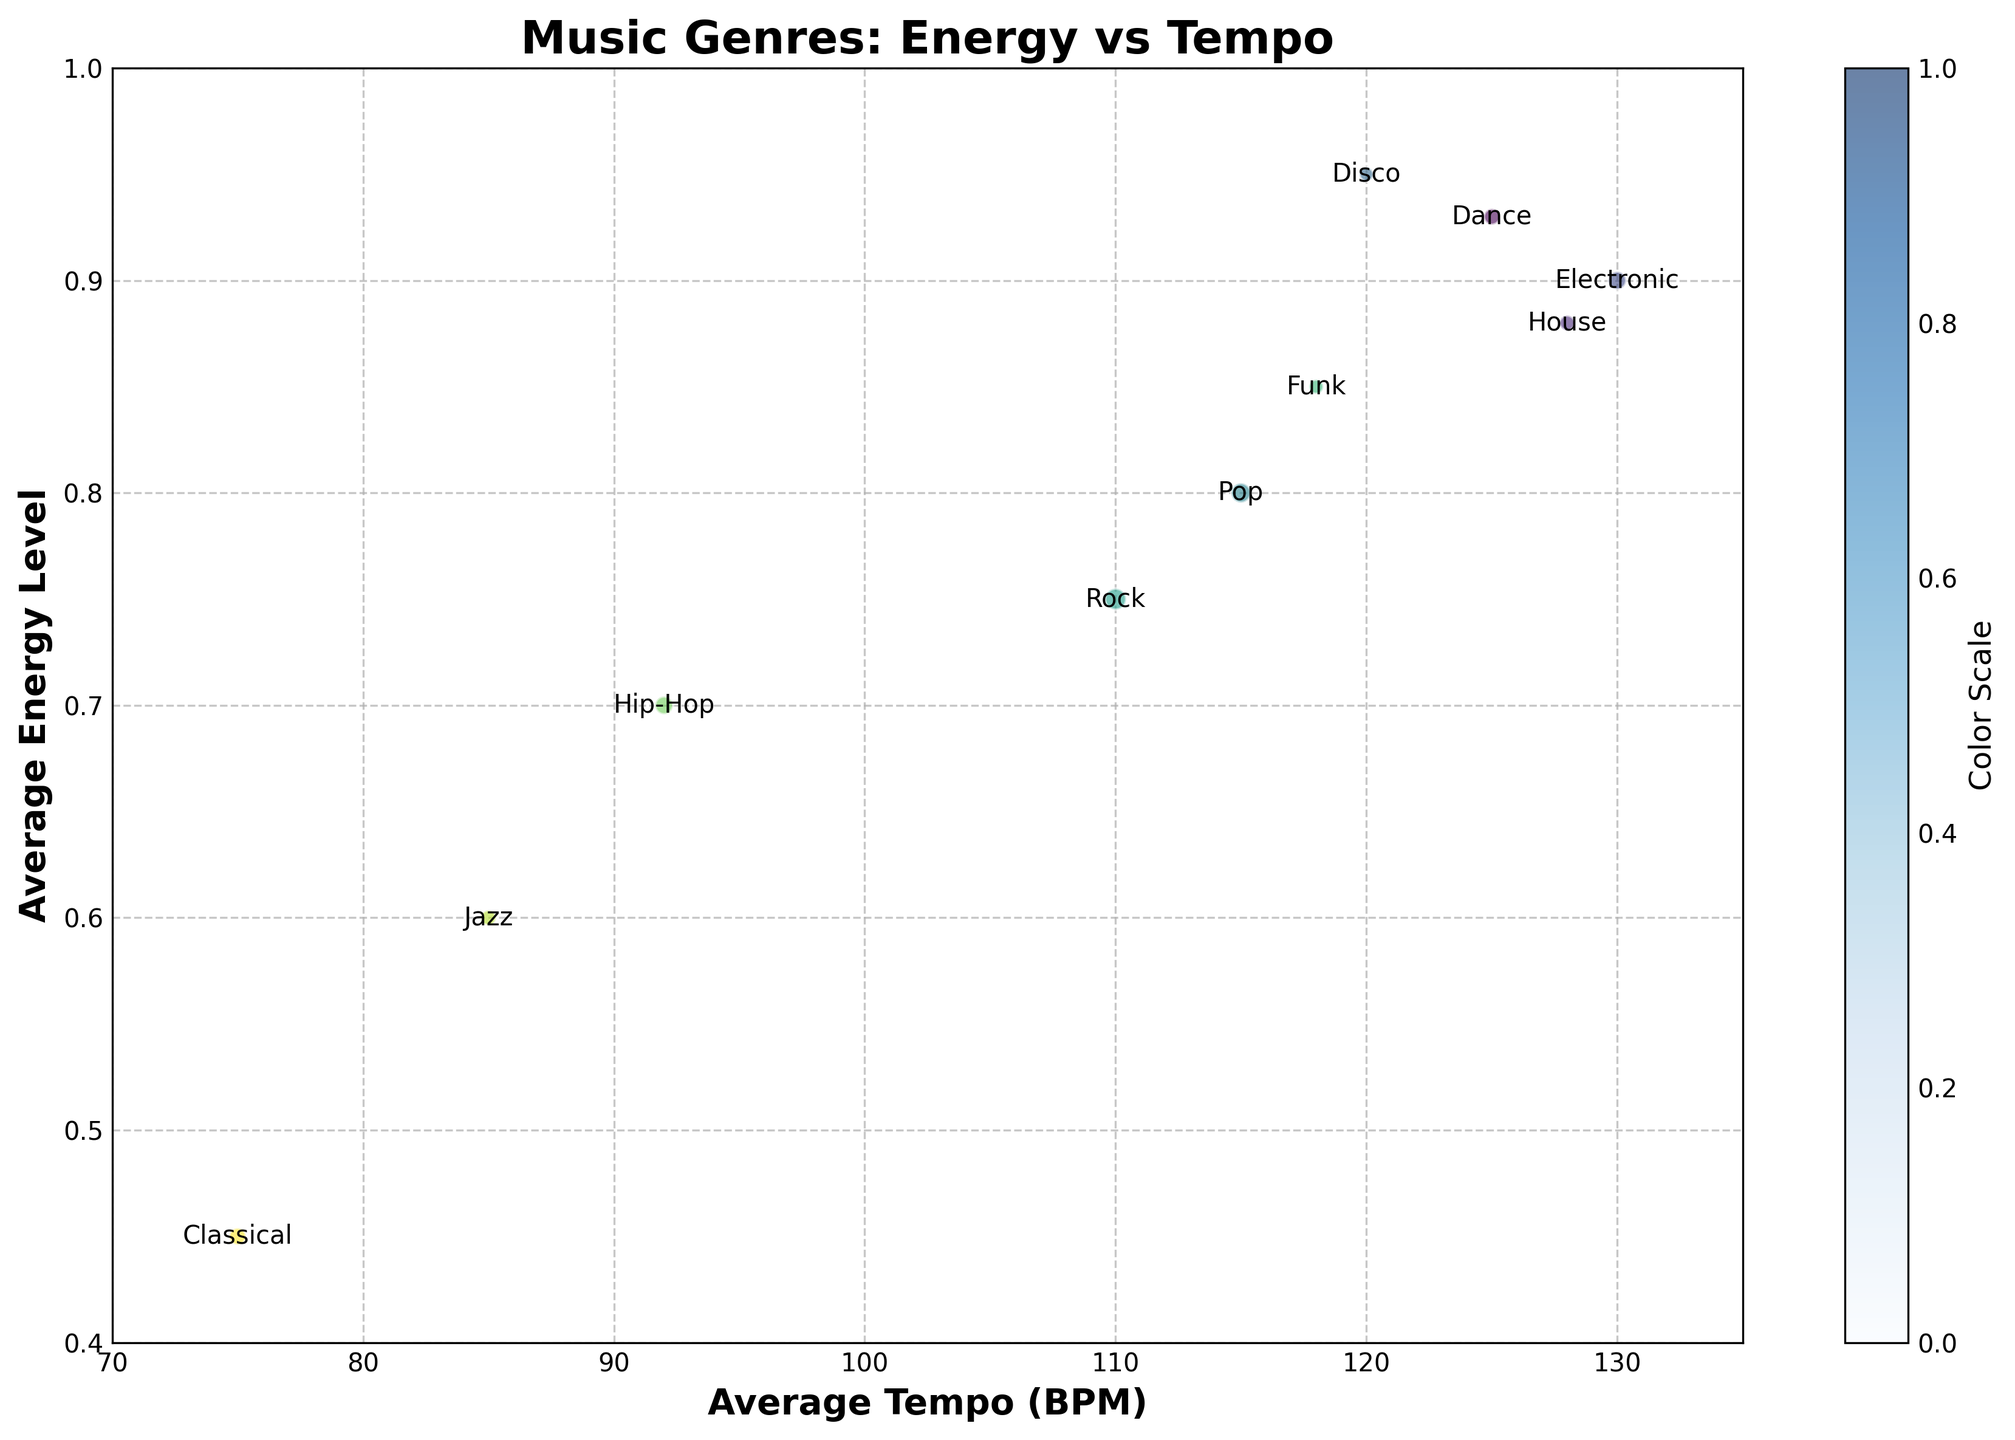What is the title of the figure? The title of the figure is prominently displayed at the top. Upon reading the text, it states "Music Genres: Energy vs Tempo"
Answer: Music Genres: Energy vs Tempo How many genres are represented in the figure? Each genre is labeled on the scatter plot. By counting the number of distinct labels, we find there are 10 genres.
Answer: 10 Which genre has the highest average energy level? The highest average energy level can be identified by finding the bubble that is positioned highest on the y-axis. This is the bubble labeled as Disco.
Answer: Disco What is the average tempo of Pop music? Locate the label "Pop" on the scatter plot, and check its position on the x-axis. The value where it aligns with the x-axis is 115 BPM.
Answer: 115 BPM Which genre has the largest number of songs? The size of the bubbles represents the number of songs. The largest bubble corresponds to Rock, indicating it has the most songs.
Answer: Rock What is the difference in average energy level between Rock and Classical music? Identify the positions of Rock and Classical on the y-axis. Rock has a value of 0.75 and Classical has 0.45. Subtract 0.45 from 0.75.
Answer: 0.30 Which genre is closest to having an average tempo of 120 BPM? On the x-axis, look for the genre label closest to 120 BPM. Disco is plotted at 120 BPM, making it the closest.
Answer: Disco How does the average tempo of House compare to that of Jazz? Identify the average tempo values on the x-axis for both House (128 BPM) and Jazz (85 BPM). House has a higher average tempo than Jazz.
Answer: House's tempo is higher Which genre has the lowest average energy level? The genre with the lowest average energy level will be the bubble positioned lowest on the y-axis. This is Classical music at 0.45.
Answer: Classical What is the average energy level of Funk music? Locate the label "Funk" on the scatter plot and check its position on the y-axis. The value is 0.85.
Answer: 0.85 